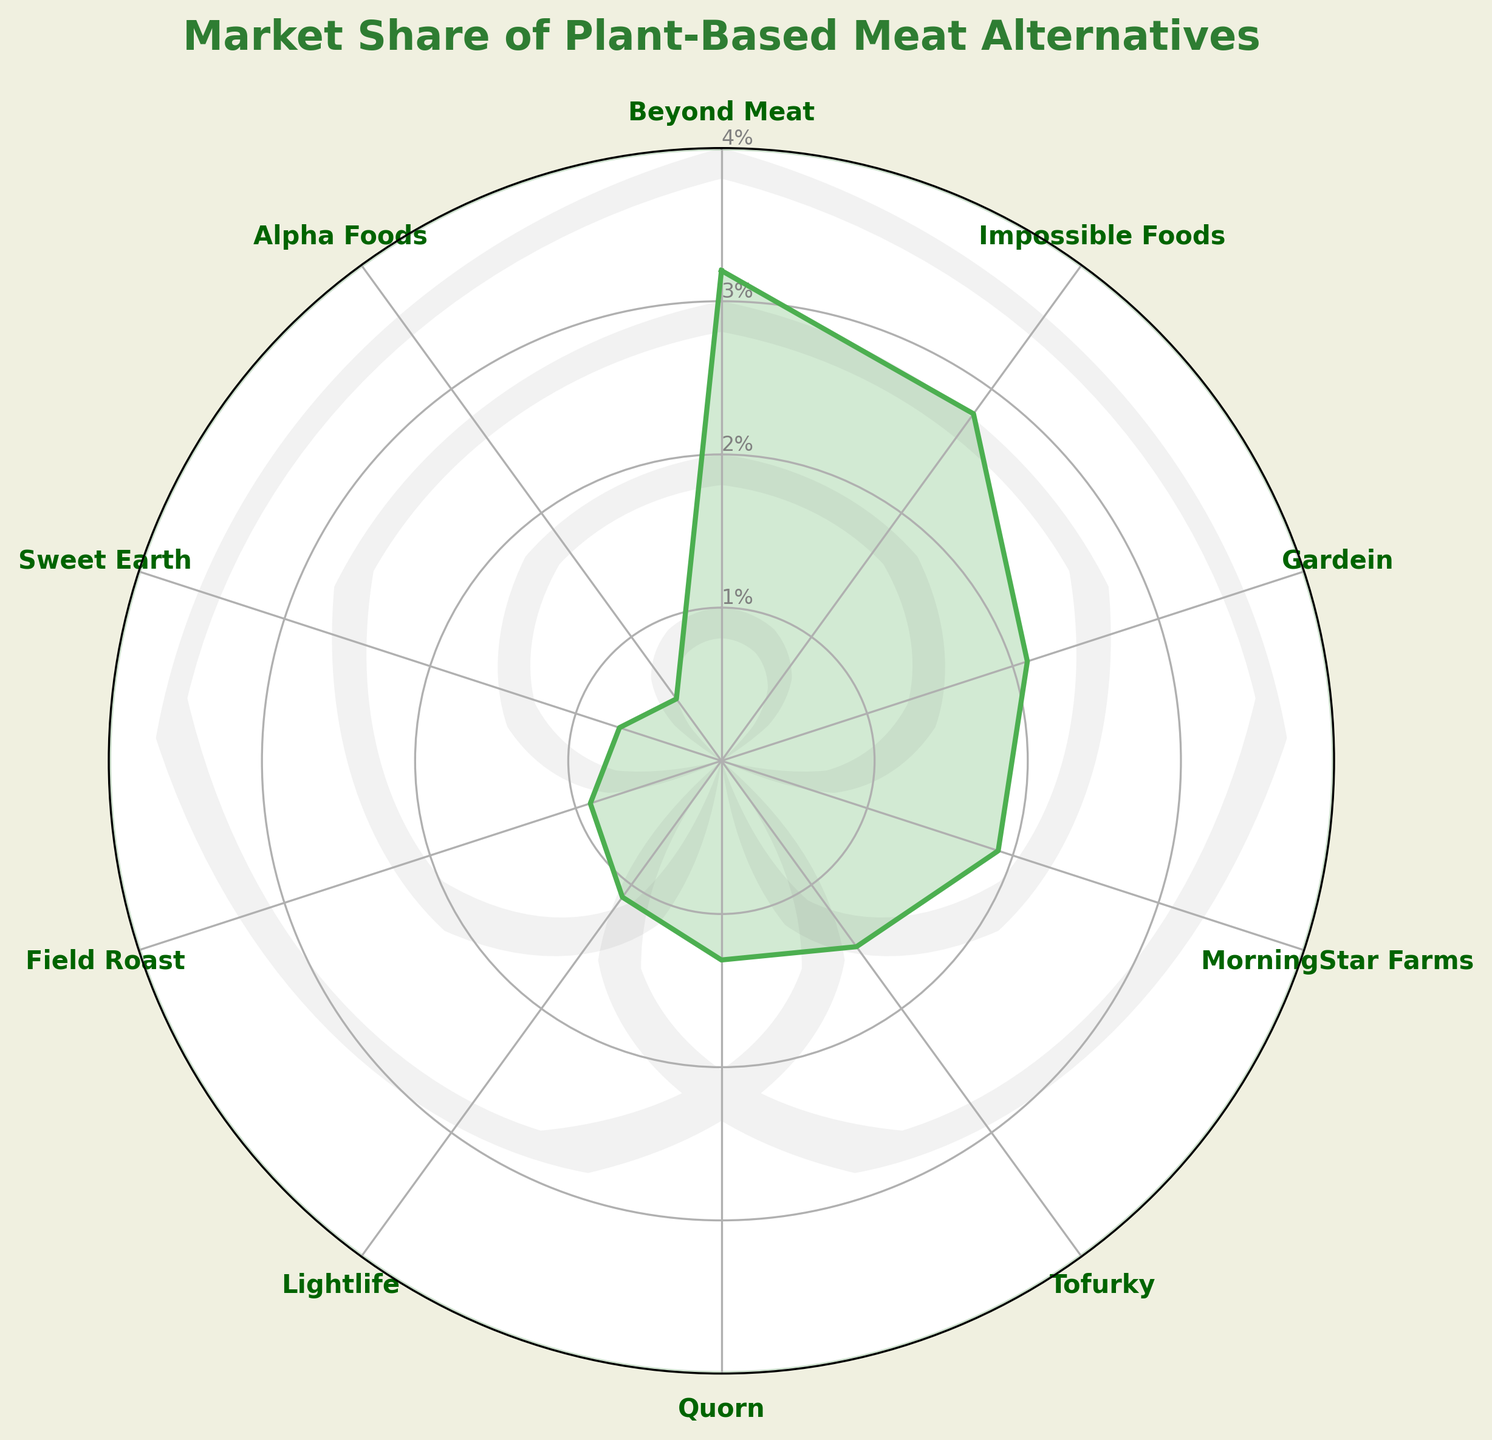What's the title of the figure? The title is displayed at the top of the figure, indicative of the visual representation's subject matter.
Answer: Market Share of Plant-Based Meat Alternatives How many categories are displayed in the figure? By observing the radial grid labels, we can count the number of distinct category names mentioned.
Answer: 10 Which company has the highest market share? By looking at the highest value on the radial axis, Beyond Meat is the closest to the outermost circle.
Answer: Beyond Meat Which company has the smallest market share? By looking at the company farthest from the outermost circle, Alpha Foods is the closest to the center.
Answer: Alpha Foods What's the market share of Impossible Foods? By locating Impossible Foods on the radial grid and reading the corresponding radial axis value, we find it is closest to 2.8%.
Answer: 2.8% What is the combined market share of Beyond Meat and Gardein? Beyond Meat has a 3.2% share, and Gardein has a 2.1% share. Adding these gives 3.2% + 2.1% = 5.3%.
Answer: 5.3% How does MorningStar Farms compare to Tofurky in terms of market share? By comparing the lengths from the center to MorningStar Farms (1.9%) and Tofurky (1.5%) on the radial grid, we can see that MorningStar Farms has a higher market share than Tofurky.
Answer: MorningStar Farms has a higher market share than Tofurky Which company has a market share closest to 1%? By observing the radial grid, both Lightlife (1.1%) and Quorn (1.3%) are close to 1%, with Lightlife being the closest.
Answer: Lightlife How would you describe the market share distribution among the companies? Observing the figure, we notice that Beyond Meat and Impossible Foods have the highest shares, while most of the others have values clustering between 1% and 2%, showing a large drop-off after the top two companies.
Answer: The market share distribution is top-heavy with rapid decline after top two companies 